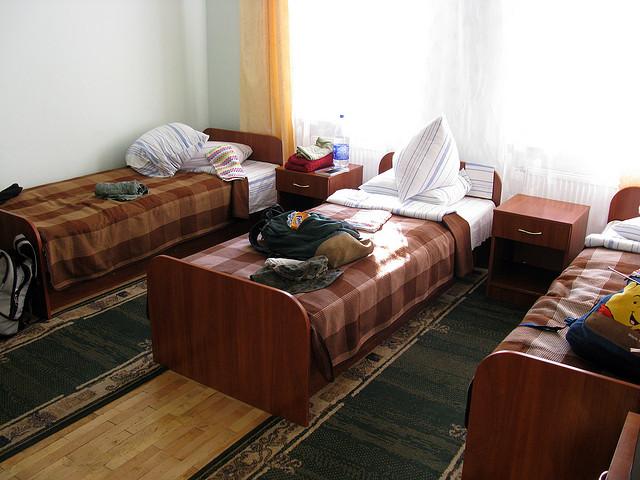How many beds?
Write a very short answer. 3. Are the backpacks going to sleep on the beds?
Write a very short answer. No. How many rugs are shown?
Answer briefly. 2. 